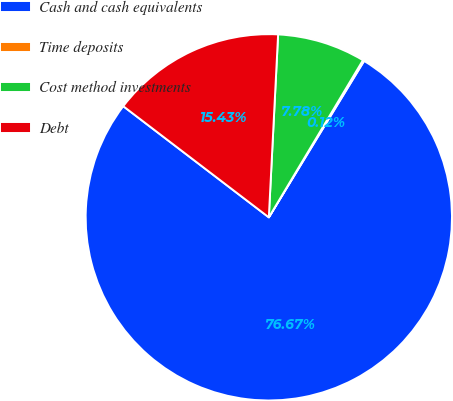Convert chart. <chart><loc_0><loc_0><loc_500><loc_500><pie_chart><fcel>Cash and cash equivalents<fcel>Time deposits<fcel>Cost method investments<fcel>Debt<nl><fcel>76.67%<fcel>0.12%<fcel>7.78%<fcel>15.43%<nl></chart> 